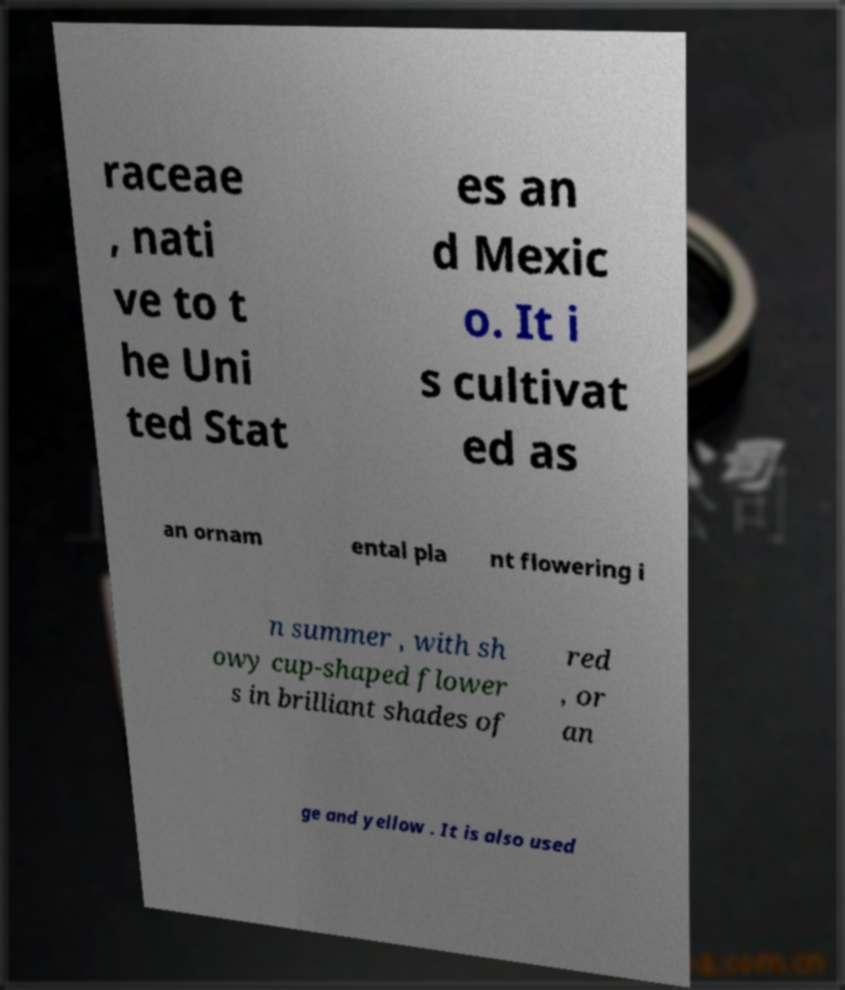I need the written content from this picture converted into text. Can you do that? raceae , nati ve to t he Uni ted Stat es an d Mexic o. It i s cultivat ed as an ornam ental pla nt flowering i n summer , with sh owy cup-shaped flower s in brilliant shades of red , or an ge and yellow . It is also used 